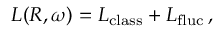<formula> <loc_0><loc_0><loc_500><loc_500>L ( R , \omega ) = L _ { c l a s s } + L _ { f l u c } \, ,</formula> 